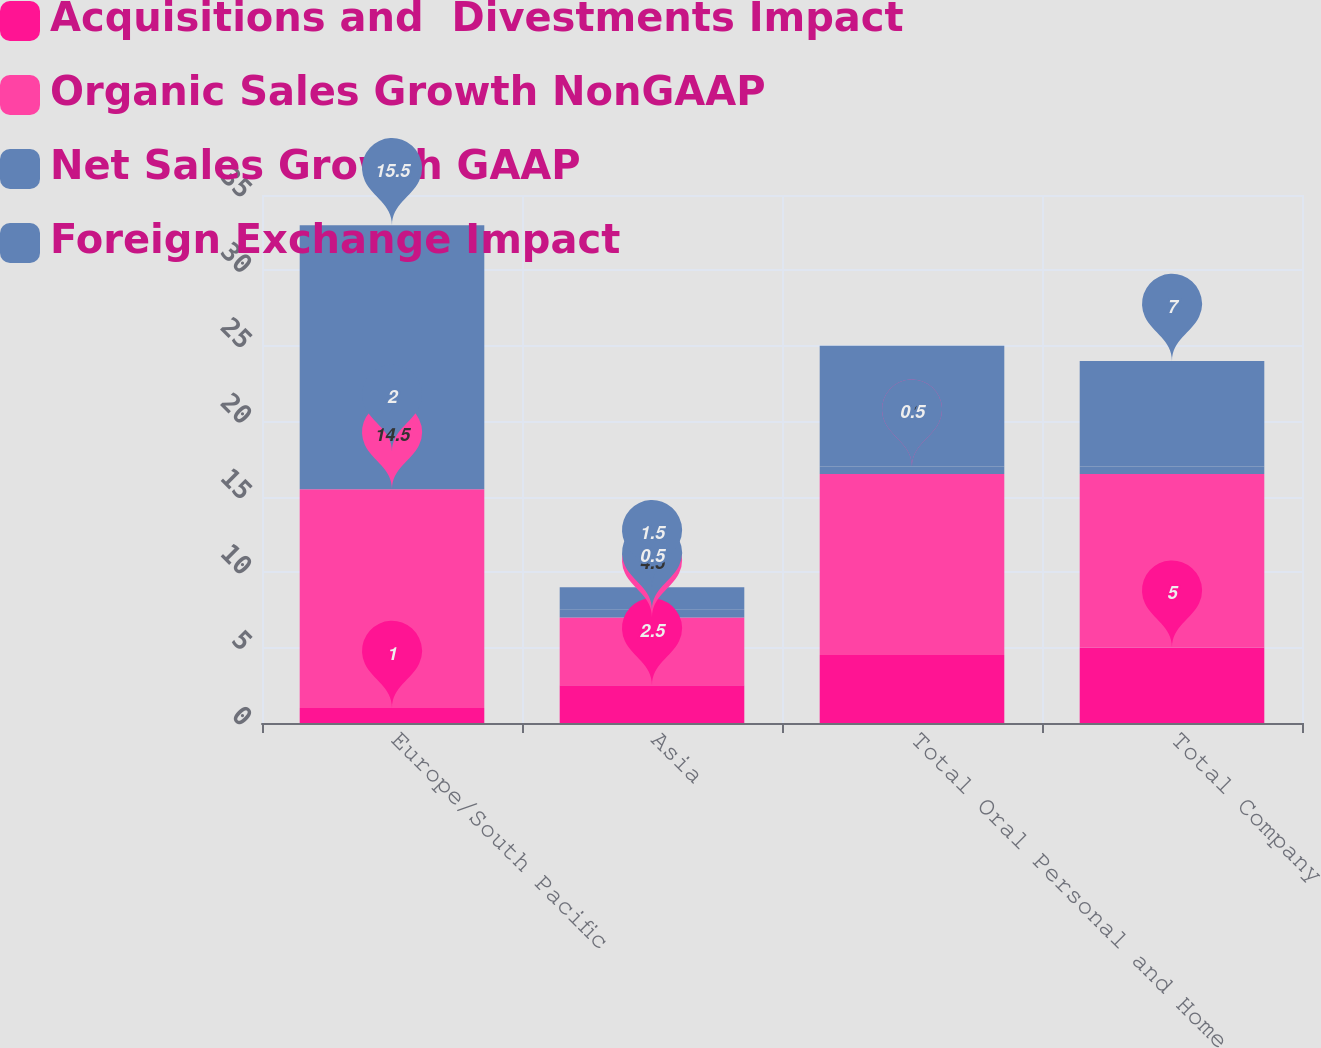Convert chart. <chart><loc_0><loc_0><loc_500><loc_500><stacked_bar_chart><ecel><fcel>Europe/South Pacific<fcel>Asia<fcel>Total Oral Personal and Home<fcel>Total Company<nl><fcel>Acquisitions and  Divestments Impact<fcel>1<fcel>2.5<fcel>4.5<fcel>5<nl><fcel>Organic Sales Growth NonGAAP<fcel>14.5<fcel>4.5<fcel>12<fcel>11.5<nl><fcel>Net Sales Growth GAAP<fcel>2<fcel>0.5<fcel>0.5<fcel>0.5<nl><fcel>Foreign Exchange Impact<fcel>15.5<fcel>1.5<fcel>8<fcel>7<nl></chart> 